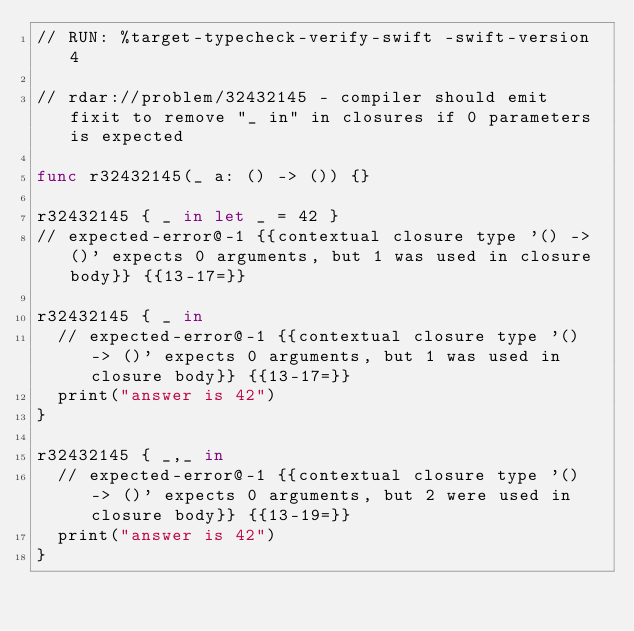Convert code to text. <code><loc_0><loc_0><loc_500><loc_500><_Swift_>// RUN: %target-typecheck-verify-swift -swift-version 4

// rdar://problem/32432145 - compiler should emit fixit to remove "_ in" in closures if 0 parameters is expected

func r32432145(_ a: () -> ()) {}

r32432145 { _ in let _ = 42 }
// expected-error@-1 {{contextual closure type '() -> ()' expects 0 arguments, but 1 was used in closure body}} {{13-17=}}

r32432145 { _ in
  // expected-error@-1 {{contextual closure type '() -> ()' expects 0 arguments, but 1 was used in closure body}} {{13-17=}}
  print("answer is 42")
}

r32432145 { _,_ in
  // expected-error@-1 {{contextual closure type '() -> ()' expects 0 arguments, but 2 were used in closure body}} {{13-19=}}
  print("answer is 42")
}
</code> 